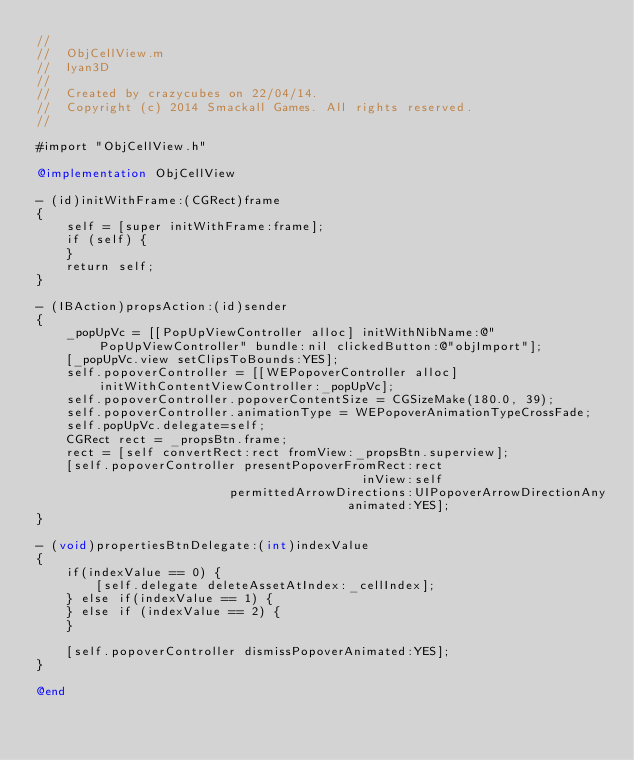Convert code to text. <code><loc_0><loc_0><loc_500><loc_500><_ObjectiveC_>//
//  ObjCellView.m
//  Iyan3D
//
//  Created by crazycubes on 22/04/14.
//  Copyright (c) 2014 Smackall Games. All rights reserved.
//

#import "ObjCellView.h"

@implementation ObjCellView

- (id)initWithFrame:(CGRect)frame
{
    self = [super initWithFrame:frame];
    if (self) {
    }
    return self;
}

- (IBAction)propsAction:(id)sender
{
    _popUpVc = [[PopUpViewController alloc] initWithNibName:@"PopUpViewController" bundle:nil clickedButton:@"objImport"];
    [_popUpVc.view setClipsToBounds:YES];
    self.popoverController = [[WEPopoverController alloc] initWithContentViewController:_popUpVc];
    self.popoverController.popoverContentSize = CGSizeMake(180.0, 39);
    self.popoverController.animationType = WEPopoverAnimationTypeCrossFade;
    self.popUpVc.delegate=self;
    CGRect rect = _propsBtn.frame;
    rect = [self convertRect:rect fromView:_propsBtn.superview];
    [self.popoverController presentPopoverFromRect:rect
                                            inView:self
                          permittedArrowDirections:UIPopoverArrowDirectionAny
                                          animated:YES];
}

- (void)propertiesBtnDelegate:(int)indexValue
{
    if(indexValue == 0) {
        [self.delegate deleteAssetAtIndex:_cellIndex];
    } else if(indexValue == 1) {
    } else if (indexValue == 2) {
    }
    
    [self.popoverController dismissPopoverAnimated:YES];
}

@end
</code> 